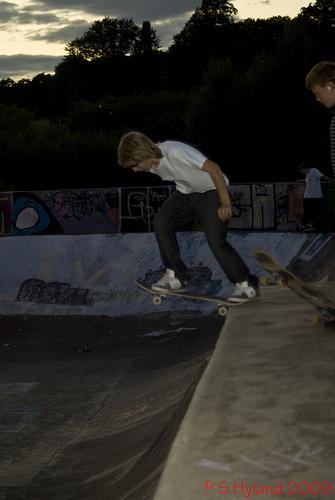For advertising purposes, highlight the key features of the skateboard present in this image. This high-performance skateboard features durable wheels, sleek bearings, and offers excellent balancing, perfect for skaters of all levels. Which object in the image indicates ownership and protection of the photo? The copyright symbol, along with the copyright owner's name and the year of photo creation in red print. Provide information about the skateboarder's physical appearance. The skateboarder has short, blonde hair and is wearing jeans and a white shirt. Imagine you are describing this image to someone who can't see it. Provide a vivid description focusing on the main subject. A young skateboarder with short blonde hair is wearing a white t-shirt and black pants. He is balancing on the edge of a grey concrete ramp, about to ride down with focus and determination. Can you identify the color of the skateboarder's outfit and the type of footwear he's wearing? The skateboarder is wearing a white short sleeve t-shirt, black pants, and grey and white tennis shoes. Describe three important details about the skateboard itself in the image. The skateboard has wheels on its bottom, bearings, and it is balancing on the curb of the ramp. What is the main activity of the person in the image? The person is skateboarding, balancing on the edge of a ramp, about to ride down. In a game of "I Spy," provide a cryptic clue for someone to locate the copyright owner's information in the image. I spy with my little eye, something red and important, just above the ground where wheels meet the ramp. In a VQA task, determine what the copyright owner is and the year of photo creation. The copyright owner is in red print, and the year of photo creation is also in red print. Give a description of the ramp and its surrounding area in the image. The ramp is made of concrete, grey in color, with tagging on it and stains on the stone surface. 